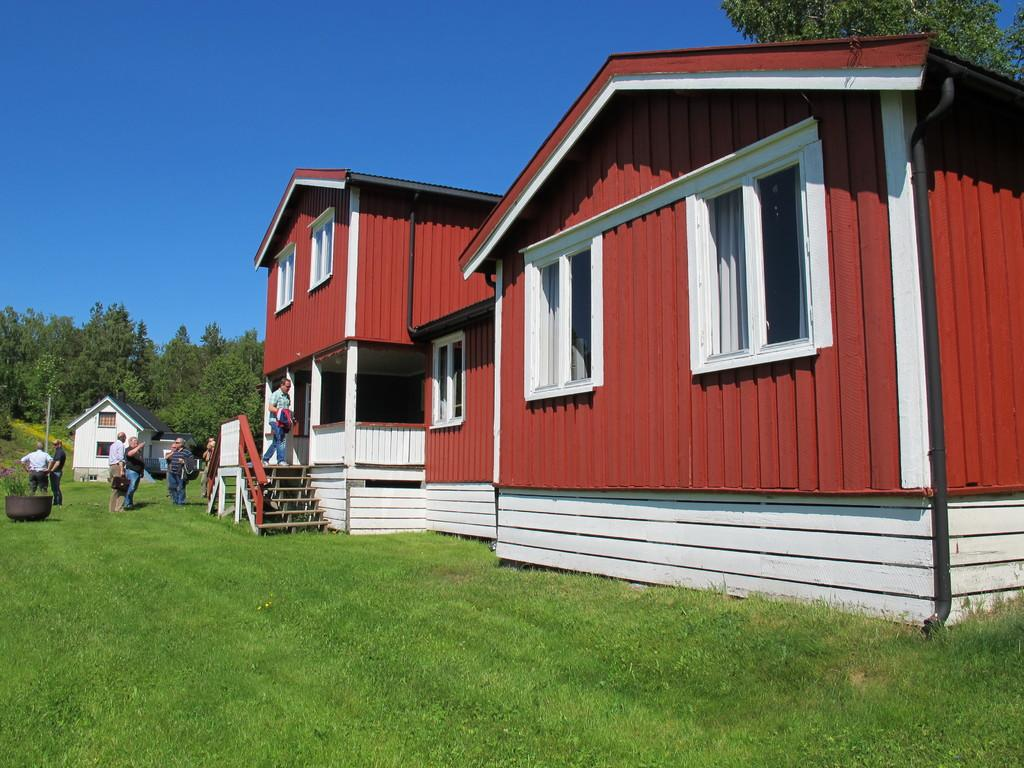What is the main subject of the image? The main subject of the image is a group of people standing. What else can be seen in the image besides the people? There are houses and trees in the image. What is visible in the background of the image? The sky is visible in the background of the image. What verse is being recited by the goat in the image? There is no goat present in the image, and therefore no verse can be recited. 